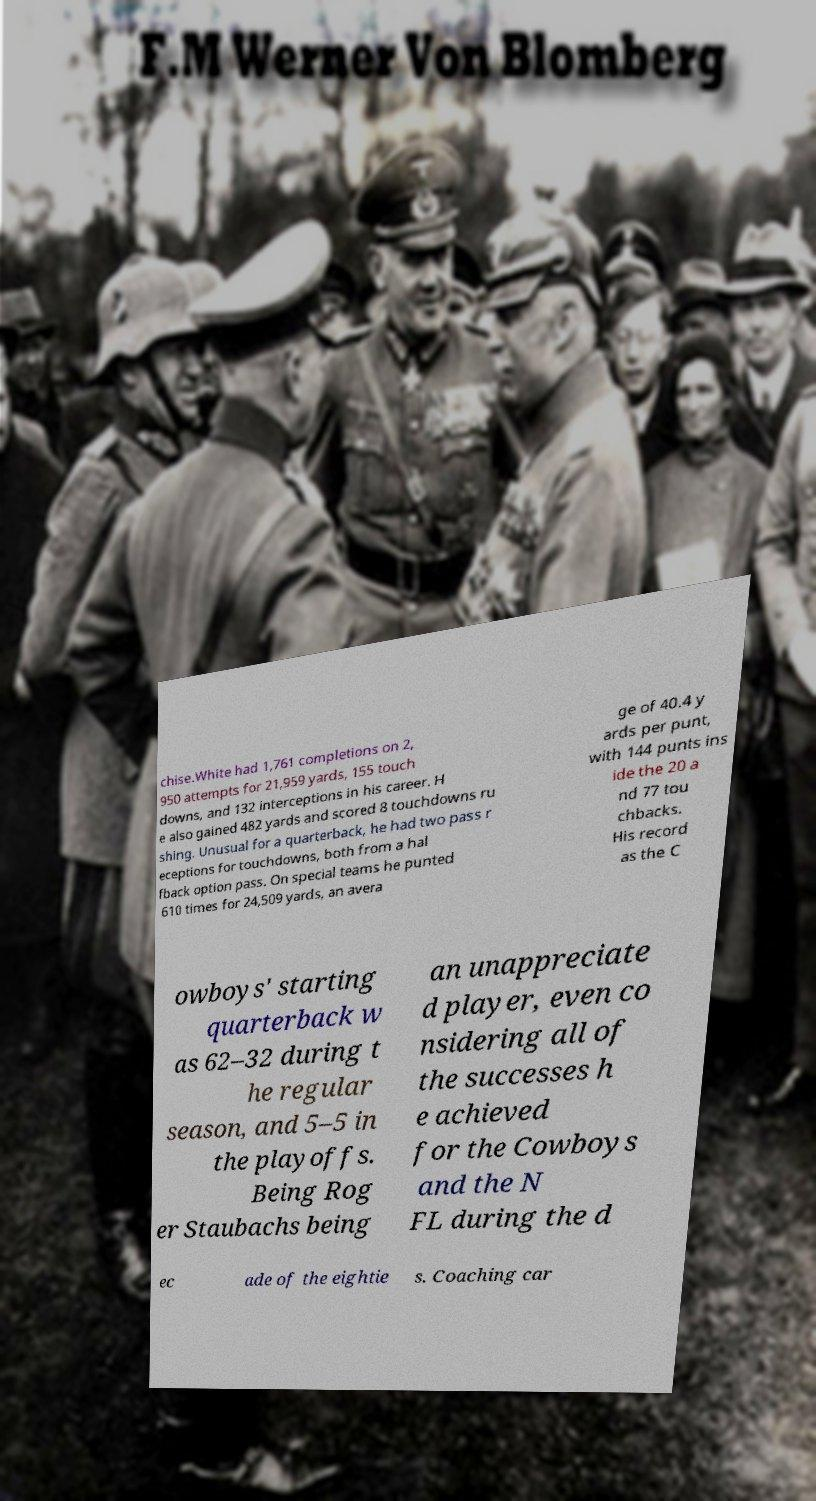Can you read and provide the text displayed in the image?This photo seems to have some interesting text. Can you extract and type it out for me? chise.White had 1,761 completions on 2, 950 attempts for 21,959 yards, 155 touch downs, and 132 interceptions in his career. H e also gained 482 yards and scored 8 touchdowns ru shing. Unusual for a quarterback, he had two pass r eceptions for touchdowns, both from a hal fback option pass. On special teams he punted 610 times for 24,509 yards, an avera ge of 40.4 y ards per punt, with 144 punts ins ide the 20 a nd 77 tou chbacks. His record as the C owboys' starting quarterback w as 62–32 during t he regular season, and 5–5 in the playoffs. Being Rog er Staubachs being an unappreciate d player, even co nsidering all of the successes h e achieved for the Cowboys and the N FL during the d ec ade of the eightie s. Coaching car 